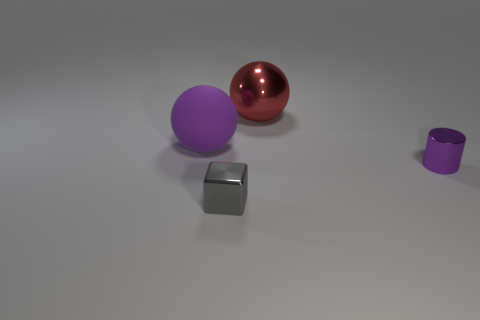Is the shape of the purple matte object the same as the large red thing?
Keep it short and to the point. Yes. There is a object that is both to the left of the shiny sphere and in front of the purple matte ball; what is its size?
Offer a terse response. Small. What material is the other big red object that is the same shape as the large rubber thing?
Keep it short and to the point. Metal. There is a big object that is left of the large object to the right of the big purple matte ball; what is it made of?
Your answer should be compact. Rubber. There is a small gray object; does it have the same shape as the tiny thing behind the gray cube?
Your response must be concise. No. How many shiny things are either small green balls or small purple things?
Keep it short and to the point. 1. There is a ball on the left side of the tiny object that is in front of the small metallic object behind the gray object; what color is it?
Give a very brief answer. Purple. What number of other objects are the same material as the red sphere?
Make the answer very short. 2. Do the rubber thing that is to the left of the tiny purple object and the large metallic thing have the same shape?
Give a very brief answer. Yes. How many small objects are red rubber blocks or red shiny spheres?
Your answer should be compact. 0. 